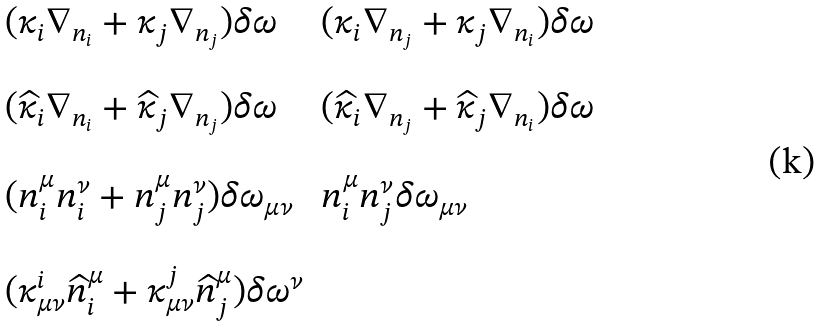<formula> <loc_0><loc_0><loc_500><loc_500>\begin{array} { l l } ( \kappa _ { i } \nabla _ { n _ { i } } + \kappa _ { j } \nabla _ { n _ { j } } ) \delta \omega & ( \kappa _ { i } \nabla _ { n _ { j } } + \kappa _ { j } \nabla _ { n _ { i } } ) \delta \omega \\ \, & \, \\ ( \widehat { \kappa } _ { i } \nabla _ { n _ { i } } + \widehat { \kappa } _ { j } \nabla _ { n _ { j } } ) \delta \omega & ( \widehat { \kappa } _ { i } \nabla _ { n _ { j } } + \widehat { \kappa } _ { j } \nabla _ { n _ { i } } ) \delta \omega \\ \, & \, \\ ( n ^ { \mu } _ { i } n ^ { \nu } _ { i } + n ^ { \mu } _ { j } n ^ { \nu } _ { j } ) \delta \omega _ { \mu \nu } & n ^ { \mu } _ { i } n ^ { \nu } _ { j } \delta \omega _ { \mu \nu } \\ \, & \, \\ ( \kappa ^ { i } _ { \mu \nu } \widehat { n } ^ { \mu } _ { i } + \kappa ^ { j } _ { \mu \nu } \widehat { n } ^ { \mu } _ { j } ) \delta \omega ^ { \nu } & \, \end{array}</formula> 